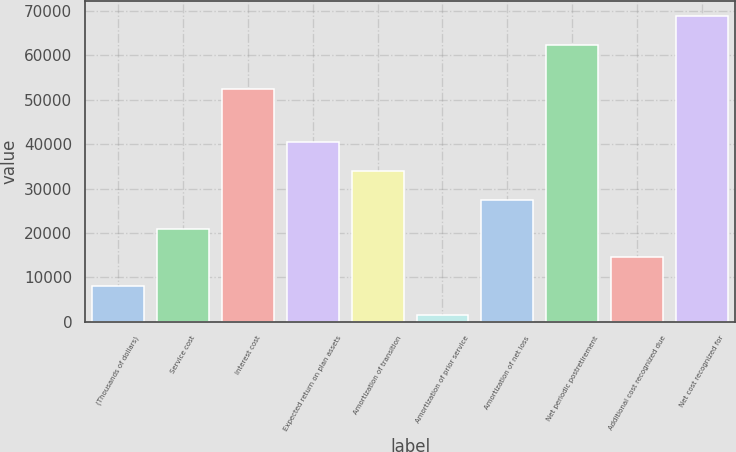Convert chart. <chart><loc_0><loc_0><loc_500><loc_500><bar_chart><fcel>(Thousands of dollars)<fcel>Service cost<fcel>Interest cost<fcel>Expected return on plan assets<fcel>Amortization of transition<fcel>Amortization of prior service<fcel>Amortization of net loss<fcel>Net periodic postretirement<fcel>Additional cost recognized due<fcel>Net cost recognized for<nl><fcel>8007.2<fcel>20955.6<fcel>52426<fcel>40378.2<fcel>33904<fcel>1533<fcel>27429.8<fcel>62392<fcel>14481.4<fcel>68866.2<nl></chart> 